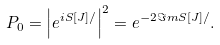<formula> <loc_0><loc_0><loc_500><loc_500>P _ { 0 } = \left | e ^ { i S [ J ] / } \right | ^ { 2 } = e ^ { - 2 { \Im m } S [ J ] / } .</formula> 